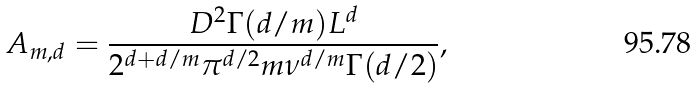Convert formula to latex. <formula><loc_0><loc_0><loc_500><loc_500>A _ { m , d } = \frac { D ^ { 2 } \Gamma ( d / m ) L ^ { d } } { 2 ^ { d + d / m } \pi ^ { d / 2 } m \nu ^ { d / m } \Gamma ( d / 2 ) } ,</formula> 